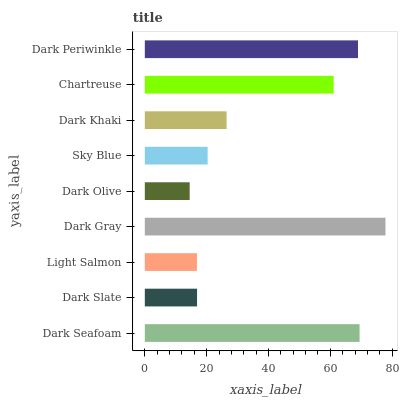Is Dark Olive the minimum?
Answer yes or no. Yes. Is Dark Gray the maximum?
Answer yes or no. Yes. Is Dark Slate the minimum?
Answer yes or no. No. Is Dark Slate the maximum?
Answer yes or no. No. Is Dark Seafoam greater than Dark Slate?
Answer yes or no. Yes. Is Dark Slate less than Dark Seafoam?
Answer yes or no. Yes. Is Dark Slate greater than Dark Seafoam?
Answer yes or no. No. Is Dark Seafoam less than Dark Slate?
Answer yes or no. No. Is Dark Khaki the high median?
Answer yes or no. Yes. Is Dark Khaki the low median?
Answer yes or no. Yes. Is Dark Periwinkle the high median?
Answer yes or no. No. Is Dark Periwinkle the low median?
Answer yes or no. No. 